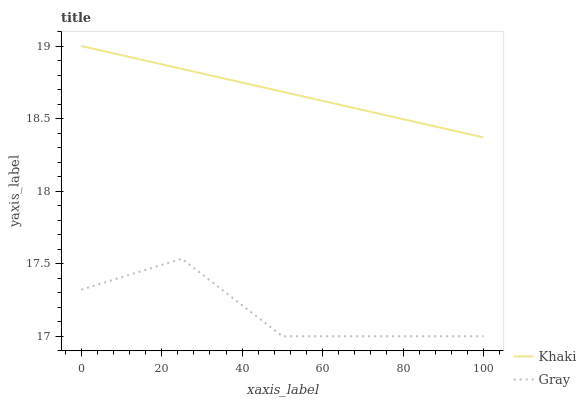Does Gray have the minimum area under the curve?
Answer yes or no. Yes. Does Khaki have the minimum area under the curve?
Answer yes or no. No. Is Khaki the roughest?
Answer yes or no. No. Does Khaki have the lowest value?
Answer yes or no. No. Is Gray less than Khaki?
Answer yes or no. Yes. Is Khaki greater than Gray?
Answer yes or no. Yes. Does Gray intersect Khaki?
Answer yes or no. No. 